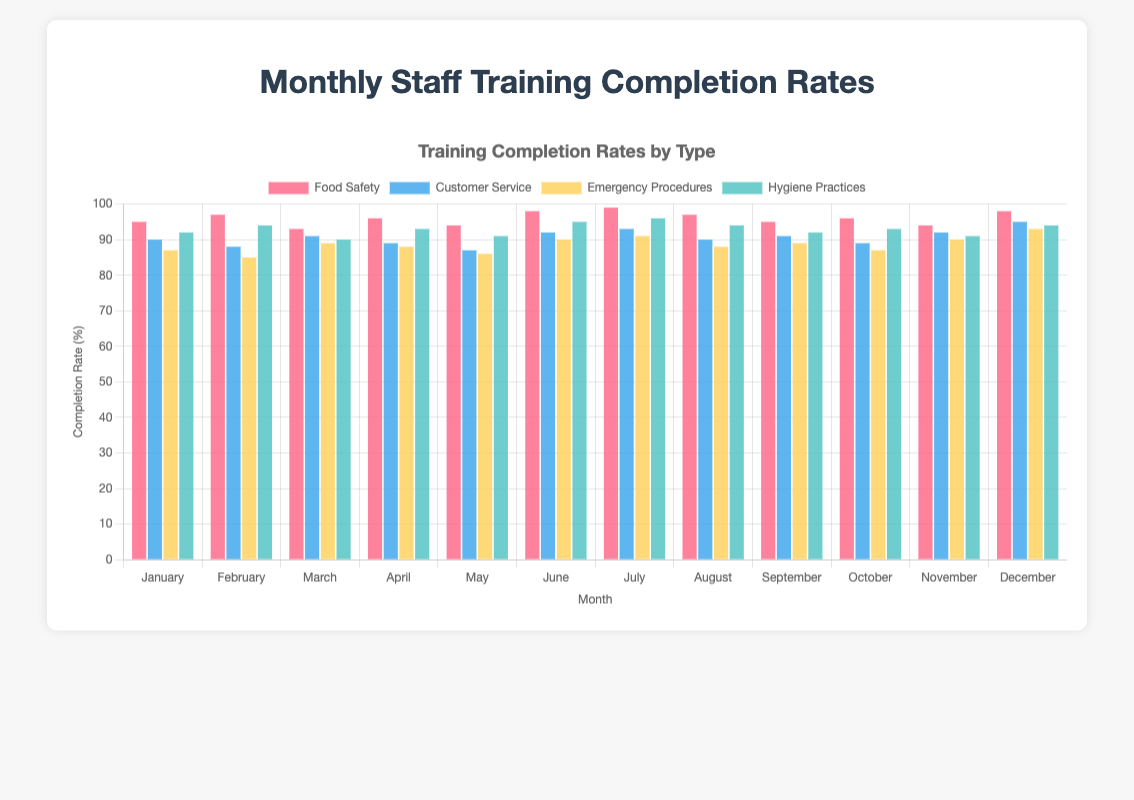What is the general trend for Food Safety training completion rates throughout the year? The Food Safety training completion rates show a consistent high across all months, with variations between 93% and 99%.
Answer: Consistently high In which month was the completion rate for Customer Service training the highest? Observing the chart, the highest bar for Customer Service training is in December.
Answer: December Compare the completion rates of Emergency Procedures and Hygiene Practices in March. Which one is higher? In March, the completion rate for Emergency Procedures is 89%, while it is 90% for Hygiene Practices. Therefore, the completion rate for Hygiene Practices is higher.
Answer: Hygiene Practices What is the average completion rate for Hygiene Practices over the year? Sum all the monthly completion rates for Hygiene Practices (92 + 94 + 90 + 93 + 91 + 95 + 96 + 94 + 92 + 93 + 91 + 94) which equals 1115. Divide by 12 to get the average: 1115/12 = 92.92.
Answer: 92.92 Which training had the lowest completion rate in May? The bars corresponding to May show the lowest completion rate for Emergency Procedures at 86%.
Answer: Emergency Procedures What is the difference in completion rates between Food Safety and Customer Service training in June? The completion rate for Food Safety in June is 98%, and for Customer Service, it’s 92%. The difference is 98% - 92% = 6%.
Answer: 6% Based on the chart, did any training type achieve a 100% completion rate in any month? Observing all the bars, no training type achieved a 100% completion rate in any month.
Answer: No Which training type had the smallest variation in completion rates across the months? By comparing the heights of the bars and their variations, Customer Service shows relatively less variation compared to the others, fluctuating mainly between 87% and 95%.
Answer: Customer Service In which month did all training types have their completion rates above 90%? Checking each month's bars, in December, all training types had completion rates above 90%.
Answer: December How did the completion rate for Food Safety training in January compare to that in July? The completion rate for Food Safety training in January was 95%, whereas in July, it was 99%.
Answer: January was lower 